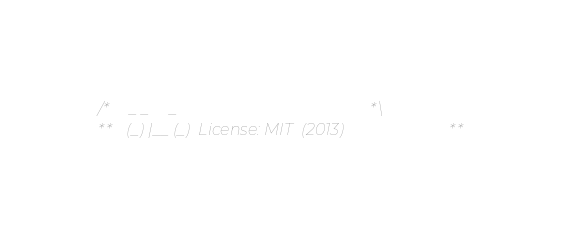Convert code to text. <code><loc_0><loc_0><loc_500><loc_500><_Scala_>/*    _ _     _                                        *\
**   (_) |__ (_)  License: MIT  (2013)                 **</code> 